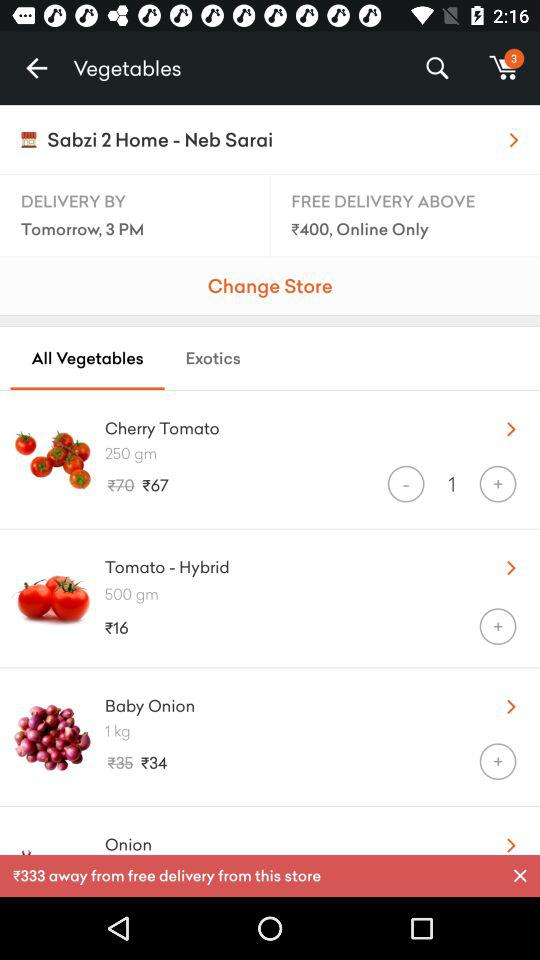How many items are in the cart? There are 3 items in the cart. 